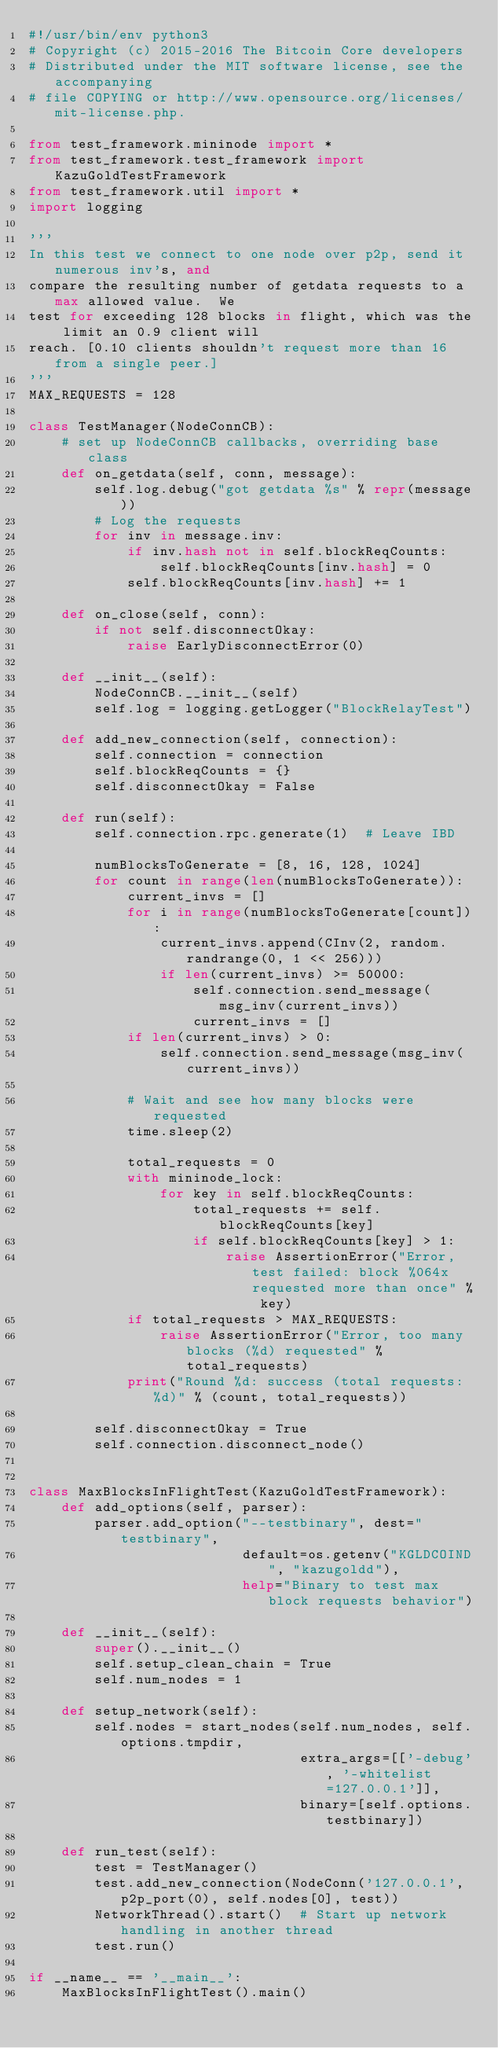<code> <loc_0><loc_0><loc_500><loc_500><_Python_>#!/usr/bin/env python3
# Copyright (c) 2015-2016 The Bitcoin Core developers
# Distributed under the MIT software license, see the accompanying
# file COPYING or http://www.opensource.org/licenses/mit-license.php.

from test_framework.mininode import *
from test_framework.test_framework import KazuGoldTestFramework
from test_framework.util import *
import logging

'''
In this test we connect to one node over p2p, send it numerous inv's, and
compare the resulting number of getdata requests to a max allowed value.  We
test for exceeding 128 blocks in flight, which was the limit an 0.9 client will
reach. [0.10 clients shouldn't request more than 16 from a single peer.]
'''
MAX_REQUESTS = 128

class TestManager(NodeConnCB):
    # set up NodeConnCB callbacks, overriding base class
    def on_getdata(self, conn, message):
        self.log.debug("got getdata %s" % repr(message))
        # Log the requests
        for inv in message.inv:
            if inv.hash not in self.blockReqCounts:
                self.blockReqCounts[inv.hash] = 0
            self.blockReqCounts[inv.hash] += 1

    def on_close(self, conn):
        if not self.disconnectOkay:
            raise EarlyDisconnectError(0)

    def __init__(self):
        NodeConnCB.__init__(self)
        self.log = logging.getLogger("BlockRelayTest")

    def add_new_connection(self, connection):
        self.connection = connection
        self.blockReqCounts = {}
        self.disconnectOkay = False

    def run(self):
        self.connection.rpc.generate(1)  # Leave IBD

        numBlocksToGenerate = [8, 16, 128, 1024]
        for count in range(len(numBlocksToGenerate)):
            current_invs = []
            for i in range(numBlocksToGenerate[count]):
                current_invs.append(CInv(2, random.randrange(0, 1 << 256)))
                if len(current_invs) >= 50000:
                    self.connection.send_message(msg_inv(current_invs))
                    current_invs = []
            if len(current_invs) > 0:
                self.connection.send_message(msg_inv(current_invs))

            # Wait and see how many blocks were requested
            time.sleep(2)

            total_requests = 0
            with mininode_lock:
                for key in self.blockReqCounts:
                    total_requests += self.blockReqCounts[key]
                    if self.blockReqCounts[key] > 1:
                        raise AssertionError("Error, test failed: block %064x requested more than once" % key)
            if total_requests > MAX_REQUESTS:
                raise AssertionError("Error, too many blocks (%d) requested" % total_requests)
            print("Round %d: success (total requests: %d)" % (count, total_requests))

        self.disconnectOkay = True
        self.connection.disconnect_node()


class MaxBlocksInFlightTest(KazuGoldTestFramework):
    def add_options(self, parser):
        parser.add_option("--testbinary", dest="testbinary",
                          default=os.getenv("KGLDCOIND", "kazugoldd"),
                          help="Binary to test max block requests behavior")

    def __init__(self):
        super().__init__()
        self.setup_clean_chain = True
        self.num_nodes = 1

    def setup_network(self):
        self.nodes = start_nodes(self.num_nodes, self.options.tmpdir,
                                 extra_args=[['-debug', '-whitelist=127.0.0.1']],
                                 binary=[self.options.testbinary])

    def run_test(self):
        test = TestManager()
        test.add_new_connection(NodeConn('127.0.0.1', p2p_port(0), self.nodes[0], test))
        NetworkThread().start()  # Start up network handling in another thread
        test.run()

if __name__ == '__main__':
    MaxBlocksInFlightTest().main()
</code> 